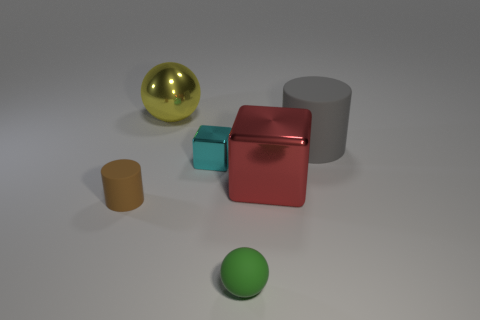Is there anything else that has the same shape as the yellow metallic thing?
Offer a terse response. Yes. What number of spheres are either small metallic things or big gray things?
Your answer should be very brief. 0. The cyan metallic thing has what shape?
Your response must be concise. Cube. There is a metal sphere; are there any large yellow metal balls on the left side of it?
Ensure brevity in your answer.  No. Does the yellow object have the same material as the cube that is to the left of the tiny green object?
Provide a succinct answer. Yes. Is the shape of the large metallic object that is in front of the yellow object the same as  the gray thing?
Your response must be concise. No. What number of large gray things are the same material as the tiny brown cylinder?
Your answer should be very brief. 1. What number of objects are either large objects that are in front of the tiny cyan metal block or large cyan spheres?
Your response must be concise. 1. The brown matte object is what size?
Ensure brevity in your answer.  Small. What is the cylinder on the right side of the large object behind the big rubber object made of?
Your answer should be compact. Rubber. 